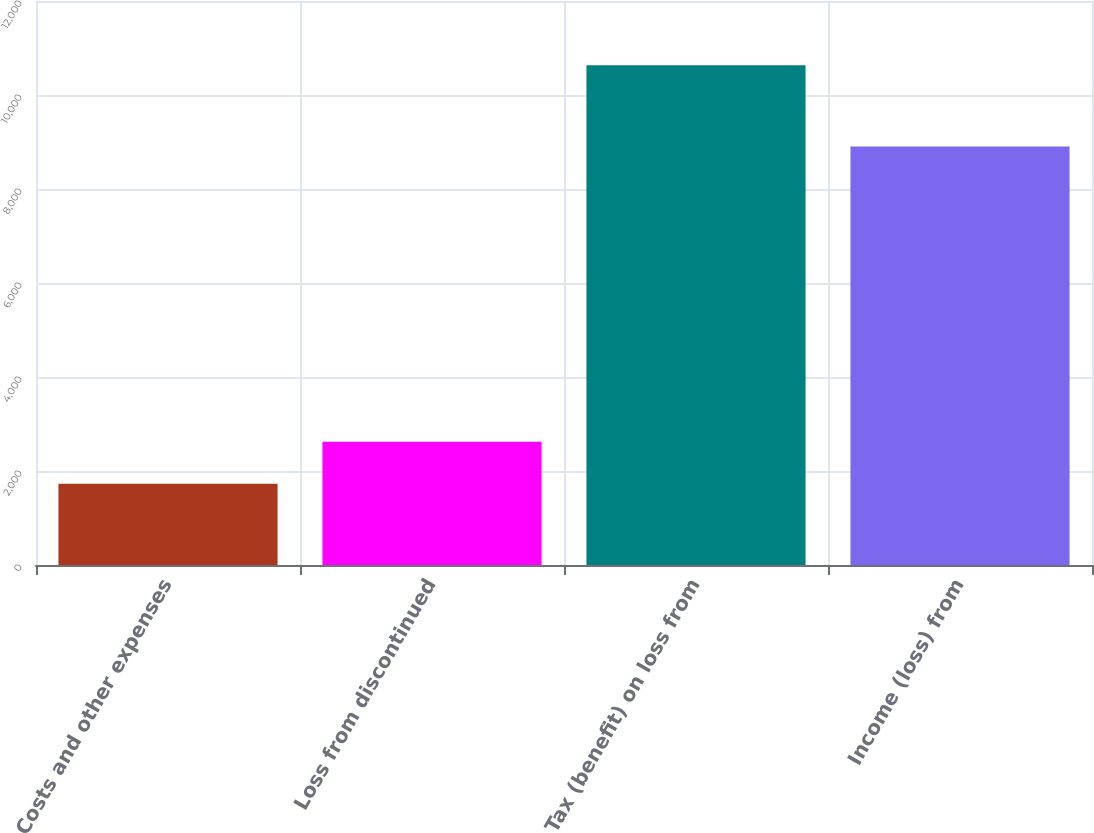Convert chart. <chart><loc_0><loc_0><loc_500><loc_500><bar_chart><fcel>Costs and other expenses<fcel>Loss from discontinued<fcel>Tax (benefit) on loss from<fcel>Income (loss) from<nl><fcel>1730<fcel>2620.5<fcel>10635<fcel>8905<nl></chart> 